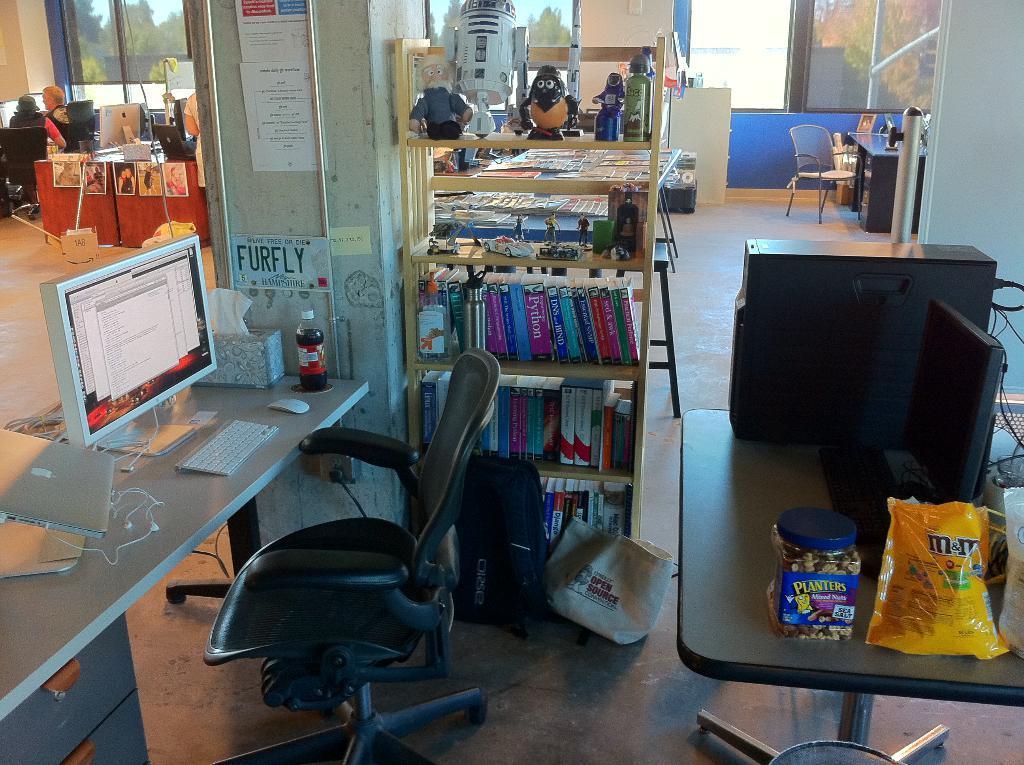Please provide a concise description of this image. In this Image I see 2 persons sitting on chairs and I see many tables and there are few things on it, I can also see a chair over here and a table and I see a rack which is full of books and other toys on it. In the background I see the windows. 